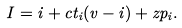<formula> <loc_0><loc_0><loc_500><loc_500>I = i + c t _ { i } ( v - i ) + z p _ { i } .</formula> 